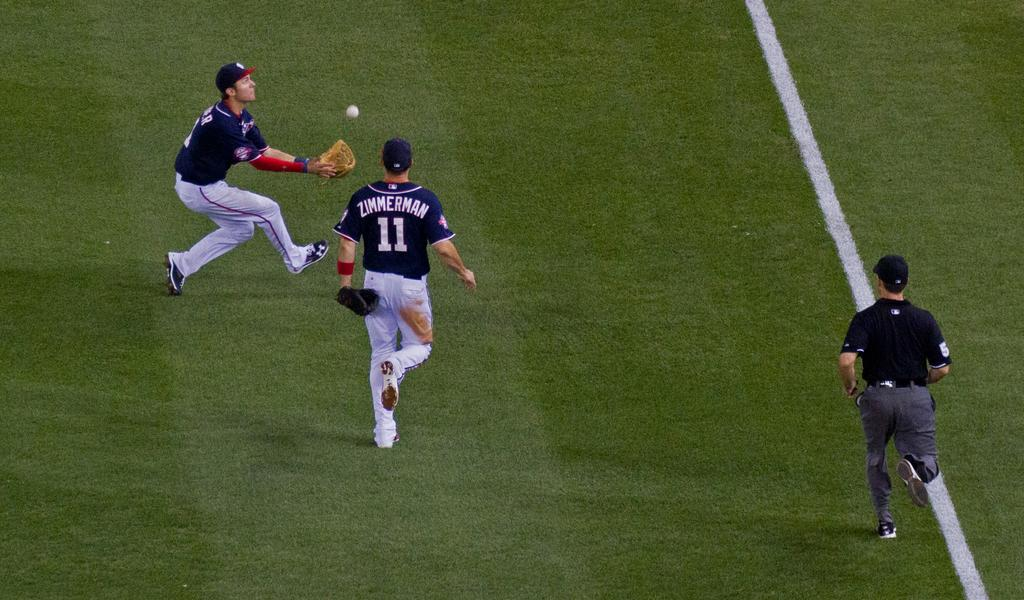<image>
Relay a brief, clear account of the picture shown. Two baseball players, one Zimmerman, race towards a ball. 